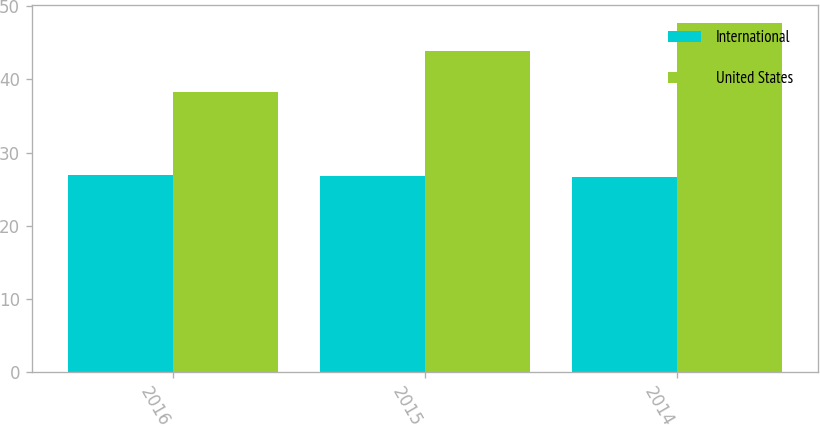Convert chart to OTSL. <chart><loc_0><loc_0><loc_500><loc_500><stacked_bar_chart><ecel><fcel>2016<fcel>2015<fcel>2014<nl><fcel>International<fcel>27<fcel>26.8<fcel>26.7<nl><fcel>United States<fcel>38.3<fcel>43.9<fcel>47.7<nl></chart> 